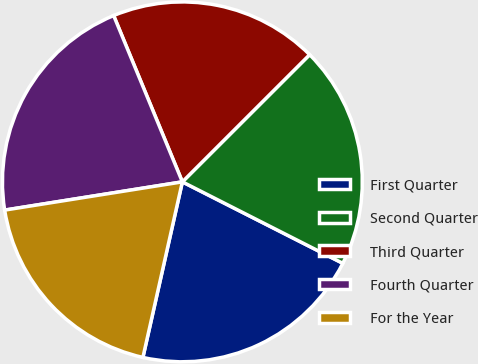<chart> <loc_0><loc_0><loc_500><loc_500><pie_chart><fcel>First Quarter<fcel>Second Quarter<fcel>Third Quarter<fcel>Fourth Quarter<fcel>For the Year<nl><fcel>21.04%<fcel>19.97%<fcel>18.74%<fcel>21.27%<fcel>18.97%<nl></chart> 